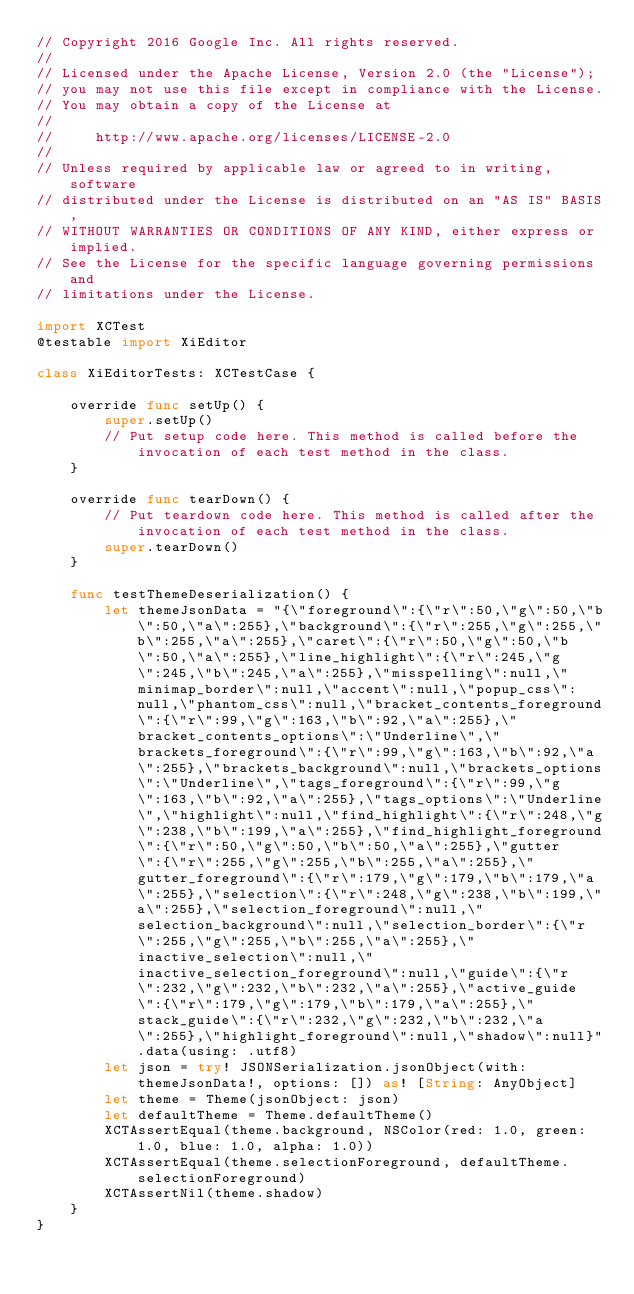<code> <loc_0><loc_0><loc_500><loc_500><_Swift_>// Copyright 2016 Google Inc. All rights reserved.
//
// Licensed under the Apache License, Version 2.0 (the "License");
// you may not use this file except in compliance with the License.
// You may obtain a copy of the License at
//
//     http://www.apache.org/licenses/LICENSE-2.0
//
// Unless required by applicable law or agreed to in writing, software
// distributed under the License is distributed on an "AS IS" BASIS,
// WITHOUT WARRANTIES OR CONDITIONS OF ANY KIND, either express or implied.
// See the License for the specific language governing permissions and
// limitations under the License.

import XCTest
@testable import XiEditor

class XiEditorTests: XCTestCase {
    
    override func setUp() {
        super.setUp()
        // Put setup code here. This method is called before the invocation of each test method in the class.
    }
    
    override func tearDown() {
        // Put teardown code here. This method is called after the invocation of each test method in the class.
        super.tearDown()
    }
    
    func testThemeDeserialization() {
        let themeJsonData = "{\"foreground\":{\"r\":50,\"g\":50,\"b\":50,\"a\":255},\"background\":{\"r\":255,\"g\":255,\"b\":255,\"a\":255},\"caret\":{\"r\":50,\"g\":50,\"b\":50,\"a\":255},\"line_highlight\":{\"r\":245,\"g\":245,\"b\":245,\"a\":255},\"misspelling\":null,\"minimap_border\":null,\"accent\":null,\"popup_css\":null,\"phantom_css\":null,\"bracket_contents_foreground\":{\"r\":99,\"g\":163,\"b\":92,\"a\":255},\"bracket_contents_options\":\"Underline\",\"brackets_foreground\":{\"r\":99,\"g\":163,\"b\":92,\"a\":255},\"brackets_background\":null,\"brackets_options\":\"Underline\",\"tags_foreground\":{\"r\":99,\"g\":163,\"b\":92,\"a\":255},\"tags_options\":\"Underline\",\"highlight\":null,\"find_highlight\":{\"r\":248,\"g\":238,\"b\":199,\"a\":255},\"find_highlight_foreground\":{\"r\":50,\"g\":50,\"b\":50,\"a\":255},\"gutter\":{\"r\":255,\"g\":255,\"b\":255,\"a\":255},\"gutter_foreground\":{\"r\":179,\"g\":179,\"b\":179,\"a\":255},\"selection\":{\"r\":248,\"g\":238,\"b\":199,\"a\":255},\"selection_foreground\":null,\"selection_background\":null,\"selection_border\":{\"r\":255,\"g\":255,\"b\":255,\"a\":255},\"inactive_selection\":null,\"inactive_selection_foreground\":null,\"guide\":{\"r\":232,\"g\":232,\"b\":232,\"a\":255},\"active_guide\":{\"r\":179,\"g\":179,\"b\":179,\"a\":255},\"stack_guide\":{\"r\":232,\"g\":232,\"b\":232,\"a\":255},\"highlight_foreground\":null,\"shadow\":null}".data(using: .utf8)
        let json = try! JSONSerialization.jsonObject(with: themeJsonData!, options: []) as! [String: AnyObject]
        let theme = Theme(jsonObject: json)
        let defaultTheme = Theme.defaultTheme()
        XCTAssertEqual(theme.background, NSColor(red: 1.0, green: 1.0, blue: 1.0, alpha: 1.0))
        XCTAssertEqual(theme.selectionForeground, defaultTheme.selectionForeground)
        XCTAssertNil(theme.shadow)
    }
}
</code> 